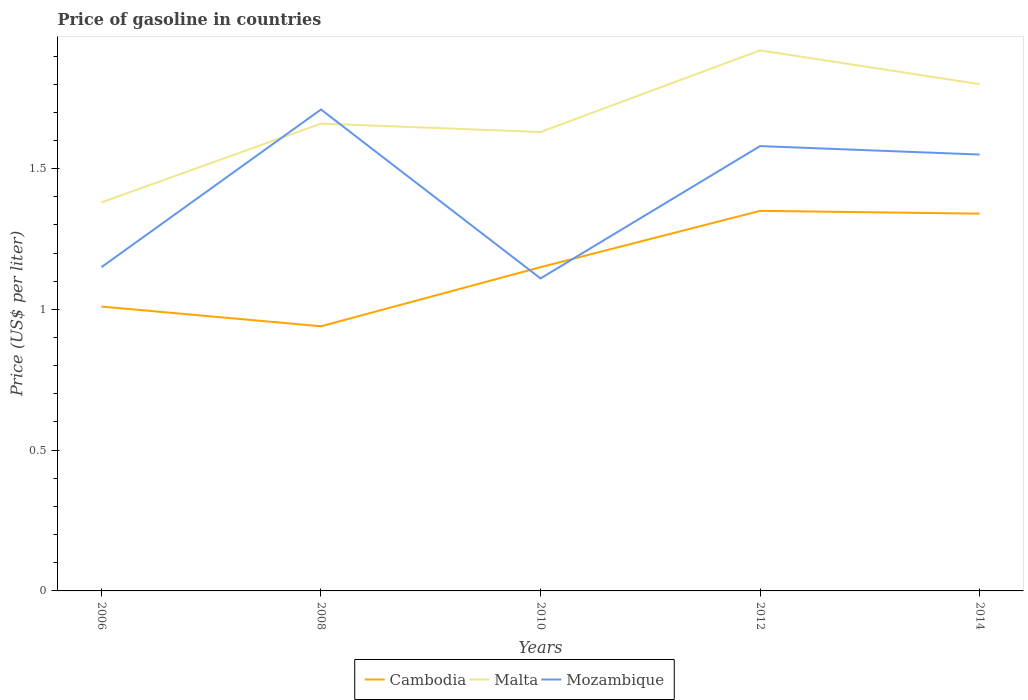How many different coloured lines are there?
Make the answer very short. 3. Is the number of lines equal to the number of legend labels?
Your response must be concise. Yes. Across all years, what is the maximum price of gasoline in Malta?
Your answer should be compact. 1.38. In which year was the price of gasoline in Mozambique maximum?
Give a very brief answer. 2010. What is the total price of gasoline in Malta in the graph?
Offer a terse response. -0.28. What is the difference between the highest and the second highest price of gasoline in Malta?
Offer a very short reply. 0.54. What is the difference between the highest and the lowest price of gasoline in Mozambique?
Offer a very short reply. 3. What is the difference between two consecutive major ticks on the Y-axis?
Offer a very short reply. 0.5. Are the values on the major ticks of Y-axis written in scientific E-notation?
Ensure brevity in your answer.  No. Does the graph contain any zero values?
Provide a short and direct response. No. Does the graph contain grids?
Provide a succinct answer. No. What is the title of the graph?
Your response must be concise. Price of gasoline in countries. What is the label or title of the Y-axis?
Provide a succinct answer. Price (US$ per liter). What is the Price (US$ per liter) of Malta in 2006?
Offer a terse response. 1.38. What is the Price (US$ per liter) in Mozambique in 2006?
Your answer should be very brief. 1.15. What is the Price (US$ per liter) of Cambodia in 2008?
Provide a short and direct response. 0.94. What is the Price (US$ per liter) of Malta in 2008?
Your answer should be compact. 1.66. What is the Price (US$ per liter) of Mozambique in 2008?
Ensure brevity in your answer.  1.71. What is the Price (US$ per liter) in Cambodia in 2010?
Ensure brevity in your answer.  1.15. What is the Price (US$ per liter) in Malta in 2010?
Offer a very short reply. 1.63. What is the Price (US$ per liter) in Mozambique in 2010?
Give a very brief answer. 1.11. What is the Price (US$ per liter) of Cambodia in 2012?
Keep it short and to the point. 1.35. What is the Price (US$ per liter) of Malta in 2012?
Your answer should be compact. 1.92. What is the Price (US$ per liter) of Mozambique in 2012?
Your answer should be very brief. 1.58. What is the Price (US$ per liter) in Cambodia in 2014?
Offer a terse response. 1.34. What is the Price (US$ per liter) of Mozambique in 2014?
Your response must be concise. 1.55. Across all years, what is the maximum Price (US$ per liter) in Cambodia?
Your answer should be compact. 1.35. Across all years, what is the maximum Price (US$ per liter) in Malta?
Provide a short and direct response. 1.92. Across all years, what is the maximum Price (US$ per liter) in Mozambique?
Offer a terse response. 1.71. Across all years, what is the minimum Price (US$ per liter) in Malta?
Offer a very short reply. 1.38. Across all years, what is the minimum Price (US$ per liter) in Mozambique?
Your response must be concise. 1.11. What is the total Price (US$ per liter) of Cambodia in the graph?
Give a very brief answer. 5.79. What is the total Price (US$ per liter) in Malta in the graph?
Provide a short and direct response. 8.39. What is the difference between the Price (US$ per liter) of Cambodia in 2006 and that in 2008?
Keep it short and to the point. 0.07. What is the difference between the Price (US$ per liter) in Malta in 2006 and that in 2008?
Your response must be concise. -0.28. What is the difference between the Price (US$ per liter) in Mozambique in 2006 and that in 2008?
Ensure brevity in your answer.  -0.56. What is the difference between the Price (US$ per liter) of Cambodia in 2006 and that in 2010?
Offer a very short reply. -0.14. What is the difference between the Price (US$ per liter) in Mozambique in 2006 and that in 2010?
Provide a succinct answer. 0.04. What is the difference between the Price (US$ per liter) of Cambodia in 2006 and that in 2012?
Your answer should be very brief. -0.34. What is the difference between the Price (US$ per liter) of Malta in 2006 and that in 2012?
Ensure brevity in your answer.  -0.54. What is the difference between the Price (US$ per liter) in Mozambique in 2006 and that in 2012?
Your answer should be compact. -0.43. What is the difference between the Price (US$ per liter) of Cambodia in 2006 and that in 2014?
Your answer should be very brief. -0.33. What is the difference between the Price (US$ per liter) of Malta in 2006 and that in 2014?
Your answer should be very brief. -0.42. What is the difference between the Price (US$ per liter) of Cambodia in 2008 and that in 2010?
Give a very brief answer. -0.21. What is the difference between the Price (US$ per liter) in Malta in 2008 and that in 2010?
Ensure brevity in your answer.  0.03. What is the difference between the Price (US$ per liter) of Cambodia in 2008 and that in 2012?
Give a very brief answer. -0.41. What is the difference between the Price (US$ per liter) of Malta in 2008 and that in 2012?
Your answer should be very brief. -0.26. What is the difference between the Price (US$ per liter) of Mozambique in 2008 and that in 2012?
Provide a succinct answer. 0.13. What is the difference between the Price (US$ per liter) of Cambodia in 2008 and that in 2014?
Give a very brief answer. -0.4. What is the difference between the Price (US$ per liter) in Malta in 2008 and that in 2014?
Your answer should be very brief. -0.14. What is the difference between the Price (US$ per liter) in Mozambique in 2008 and that in 2014?
Offer a terse response. 0.16. What is the difference between the Price (US$ per liter) of Malta in 2010 and that in 2012?
Your response must be concise. -0.29. What is the difference between the Price (US$ per liter) in Mozambique in 2010 and that in 2012?
Provide a succinct answer. -0.47. What is the difference between the Price (US$ per liter) in Cambodia in 2010 and that in 2014?
Offer a very short reply. -0.19. What is the difference between the Price (US$ per liter) of Malta in 2010 and that in 2014?
Offer a terse response. -0.17. What is the difference between the Price (US$ per liter) of Mozambique in 2010 and that in 2014?
Provide a short and direct response. -0.44. What is the difference between the Price (US$ per liter) of Cambodia in 2012 and that in 2014?
Offer a very short reply. 0.01. What is the difference between the Price (US$ per liter) of Malta in 2012 and that in 2014?
Ensure brevity in your answer.  0.12. What is the difference between the Price (US$ per liter) of Mozambique in 2012 and that in 2014?
Give a very brief answer. 0.03. What is the difference between the Price (US$ per liter) in Cambodia in 2006 and the Price (US$ per liter) in Malta in 2008?
Offer a very short reply. -0.65. What is the difference between the Price (US$ per liter) of Cambodia in 2006 and the Price (US$ per liter) of Mozambique in 2008?
Your answer should be very brief. -0.7. What is the difference between the Price (US$ per liter) of Malta in 2006 and the Price (US$ per liter) of Mozambique in 2008?
Provide a succinct answer. -0.33. What is the difference between the Price (US$ per liter) in Cambodia in 2006 and the Price (US$ per liter) in Malta in 2010?
Your response must be concise. -0.62. What is the difference between the Price (US$ per liter) of Malta in 2006 and the Price (US$ per liter) of Mozambique in 2010?
Keep it short and to the point. 0.27. What is the difference between the Price (US$ per liter) in Cambodia in 2006 and the Price (US$ per liter) in Malta in 2012?
Your response must be concise. -0.91. What is the difference between the Price (US$ per liter) of Cambodia in 2006 and the Price (US$ per liter) of Mozambique in 2012?
Your response must be concise. -0.57. What is the difference between the Price (US$ per liter) of Cambodia in 2006 and the Price (US$ per liter) of Malta in 2014?
Make the answer very short. -0.79. What is the difference between the Price (US$ per liter) of Cambodia in 2006 and the Price (US$ per liter) of Mozambique in 2014?
Offer a very short reply. -0.54. What is the difference between the Price (US$ per liter) in Malta in 2006 and the Price (US$ per liter) in Mozambique in 2014?
Your answer should be very brief. -0.17. What is the difference between the Price (US$ per liter) of Cambodia in 2008 and the Price (US$ per liter) of Malta in 2010?
Provide a short and direct response. -0.69. What is the difference between the Price (US$ per liter) of Cambodia in 2008 and the Price (US$ per liter) of Mozambique in 2010?
Offer a very short reply. -0.17. What is the difference between the Price (US$ per liter) in Malta in 2008 and the Price (US$ per liter) in Mozambique in 2010?
Offer a terse response. 0.55. What is the difference between the Price (US$ per liter) in Cambodia in 2008 and the Price (US$ per liter) in Malta in 2012?
Keep it short and to the point. -0.98. What is the difference between the Price (US$ per liter) of Cambodia in 2008 and the Price (US$ per liter) of Mozambique in 2012?
Give a very brief answer. -0.64. What is the difference between the Price (US$ per liter) of Malta in 2008 and the Price (US$ per liter) of Mozambique in 2012?
Offer a terse response. 0.08. What is the difference between the Price (US$ per liter) in Cambodia in 2008 and the Price (US$ per liter) in Malta in 2014?
Offer a terse response. -0.86. What is the difference between the Price (US$ per liter) in Cambodia in 2008 and the Price (US$ per liter) in Mozambique in 2014?
Your answer should be compact. -0.61. What is the difference between the Price (US$ per liter) of Malta in 2008 and the Price (US$ per liter) of Mozambique in 2014?
Keep it short and to the point. 0.11. What is the difference between the Price (US$ per liter) of Cambodia in 2010 and the Price (US$ per liter) of Malta in 2012?
Offer a terse response. -0.77. What is the difference between the Price (US$ per liter) in Cambodia in 2010 and the Price (US$ per liter) in Mozambique in 2012?
Your response must be concise. -0.43. What is the difference between the Price (US$ per liter) of Malta in 2010 and the Price (US$ per liter) of Mozambique in 2012?
Ensure brevity in your answer.  0.05. What is the difference between the Price (US$ per liter) of Cambodia in 2010 and the Price (US$ per liter) of Malta in 2014?
Your answer should be compact. -0.65. What is the difference between the Price (US$ per liter) of Cambodia in 2010 and the Price (US$ per liter) of Mozambique in 2014?
Your answer should be compact. -0.4. What is the difference between the Price (US$ per liter) in Malta in 2010 and the Price (US$ per liter) in Mozambique in 2014?
Your answer should be compact. 0.08. What is the difference between the Price (US$ per liter) in Cambodia in 2012 and the Price (US$ per liter) in Malta in 2014?
Provide a succinct answer. -0.45. What is the difference between the Price (US$ per liter) of Malta in 2012 and the Price (US$ per liter) of Mozambique in 2014?
Offer a very short reply. 0.37. What is the average Price (US$ per liter) of Cambodia per year?
Make the answer very short. 1.16. What is the average Price (US$ per liter) in Malta per year?
Your response must be concise. 1.68. What is the average Price (US$ per liter) in Mozambique per year?
Your response must be concise. 1.42. In the year 2006, what is the difference between the Price (US$ per liter) of Cambodia and Price (US$ per liter) of Malta?
Give a very brief answer. -0.37. In the year 2006, what is the difference between the Price (US$ per liter) of Cambodia and Price (US$ per liter) of Mozambique?
Keep it short and to the point. -0.14. In the year 2006, what is the difference between the Price (US$ per liter) in Malta and Price (US$ per liter) in Mozambique?
Make the answer very short. 0.23. In the year 2008, what is the difference between the Price (US$ per liter) of Cambodia and Price (US$ per liter) of Malta?
Your answer should be very brief. -0.72. In the year 2008, what is the difference between the Price (US$ per liter) of Cambodia and Price (US$ per liter) of Mozambique?
Your answer should be very brief. -0.77. In the year 2010, what is the difference between the Price (US$ per liter) of Cambodia and Price (US$ per liter) of Malta?
Give a very brief answer. -0.48. In the year 2010, what is the difference between the Price (US$ per liter) in Malta and Price (US$ per liter) in Mozambique?
Provide a short and direct response. 0.52. In the year 2012, what is the difference between the Price (US$ per liter) in Cambodia and Price (US$ per liter) in Malta?
Offer a very short reply. -0.57. In the year 2012, what is the difference between the Price (US$ per liter) in Cambodia and Price (US$ per liter) in Mozambique?
Provide a short and direct response. -0.23. In the year 2012, what is the difference between the Price (US$ per liter) in Malta and Price (US$ per liter) in Mozambique?
Ensure brevity in your answer.  0.34. In the year 2014, what is the difference between the Price (US$ per liter) of Cambodia and Price (US$ per liter) of Malta?
Keep it short and to the point. -0.46. In the year 2014, what is the difference between the Price (US$ per liter) in Cambodia and Price (US$ per liter) in Mozambique?
Your response must be concise. -0.21. In the year 2014, what is the difference between the Price (US$ per liter) in Malta and Price (US$ per liter) in Mozambique?
Offer a very short reply. 0.25. What is the ratio of the Price (US$ per liter) in Cambodia in 2006 to that in 2008?
Ensure brevity in your answer.  1.07. What is the ratio of the Price (US$ per liter) of Malta in 2006 to that in 2008?
Your answer should be compact. 0.83. What is the ratio of the Price (US$ per liter) in Mozambique in 2006 to that in 2008?
Offer a very short reply. 0.67. What is the ratio of the Price (US$ per liter) in Cambodia in 2006 to that in 2010?
Provide a short and direct response. 0.88. What is the ratio of the Price (US$ per liter) of Malta in 2006 to that in 2010?
Ensure brevity in your answer.  0.85. What is the ratio of the Price (US$ per liter) in Mozambique in 2006 to that in 2010?
Provide a short and direct response. 1.04. What is the ratio of the Price (US$ per liter) of Cambodia in 2006 to that in 2012?
Give a very brief answer. 0.75. What is the ratio of the Price (US$ per liter) of Malta in 2006 to that in 2012?
Your response must be concise. 0.72. What is the ratio of the Price (US$ per liter) in Mozambique in 2006 to that in 2012?
Keep it short and to the point. 0.73. What is the ratio of the Price (US$ per liter) in Cambodia in 2006 to that in 2014?
Make the answer very short. 0.75. What is the ratio of the Price (US$ per liter) of Malta in 2006 to that in 2014?
Your answer should be compact. 0.77. What is the ratio of the Price (US$ per liter) in Mozambique in 2006 to that in 2014?
Your answer should be very brief. 0.74. What is the ratio of the Price (US$ per liter) of Cambodia in 2008 to that in 2010?
Ensure brevity in your answer.  0.82. What is the ratio of the Price (US$ per liter) in Malta in 2008 to that in 2010?
Your response must be concise. 1.02. What is the ratio of the Price (US$ per liter) of Mozambique in 2008 to that in 2010?
Make the answer very short. 1.54. What is the ratio of the Price (US$ per liter) of Cambodia in 2008 to that in 2012?
Make the answer very short. 0.7. What is the ratio of the Price (US$ per liter) of Malta in 2008 to that in 2012?
Keep it short and to the point. 0.86. What is the ratio of the Price (US$ per liter) of Mozambique in 2008 to that in 2012?
Make the answer very short. 1.08. What is the ratio of the Price (US$ per liter) in Cambodia in 2008 to that in 2014?
Provide a succinct answer. 0.7. What is the ratio of the Price (US$ per liter) in Malta in 2008 to that in 2014?
Keep it short and to the point. 0.92. What is the ratio of the Price (US$ per liter) in Mozambique in 2008 to that in 2014?
Provide a succinct answer. 1.1. What is the ratio of the Price (US$ per liter) in Cambodia in 2010 to that in 2012?
Your answer should be compact. 0.85. What is the ratio of the Price (US$ per liter) of Malta in 2010 to that in 2012?
Offer a very short reply. 0.85. What is the ratio of the Price (US$ per liter) in Mozambique in 2010 to that in 2012?
Your answer should be very brief. 0.7. What is the ratio of the Price (US$ per liter) of Cambodia in 2010 to that in 2014?
Provide a succinct answer. 0.86. What is the ratio of the Price (US$ per liter) of Malta in 2010 to that in 2014?
Provide a succinct answer. 0.91. What is the ratio of the Price (US$ per liter) in Mozambique in 2010 to that in 2014?
Keep it short and to the point. 0.72. What is the ratio of the Price (US$ per liter) in Cambodia in 2012 to that in 2014?
Provide a succinct answer. 1.01. What is the ratio of the Price (US$ per liter) in Malta in 2012 to that in 2014?
Keep it short and to the point. 1.07. What is the ratio of the Price (US$ per liter) of Mozambique in 2012 to that in 2014?
Offer a terse response. 1.02. What is the difference between the highest and the second highest Price (US$ per liter) of Malta?
Your response must be concise. 0.12. What is the difference between the highest and the second highest Price (US$ per liter) of Mozambique?
Make the answer very short. 0.13. What is the difference between the highest and the lowest Price (US$ per liter) in Cambodia?
Offer a very short reply. 0.41. What is the difference between the highest and the lowest Price (US$ per liter) in Malta?
Your answer should be compact. 0.54. What is the difference between the highest and the lowest Price (US$ per liter) of Mozambique?
Offer a very short reply. 0.6. 